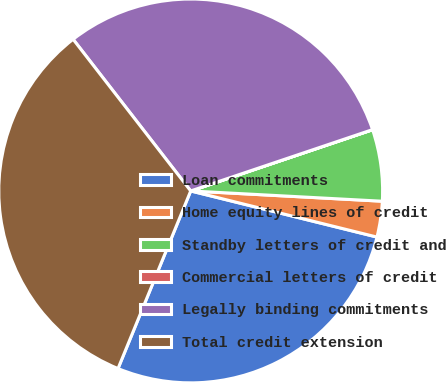Convert chart. <chart><loc_0><loc_0><loc_500><loc_500><pie_chart><fcel>Loan commitments<fcel>Home equity lines of credit<fcel>Standby letters of credit and<fcel>Commercial letters of credit<fcel>Legally binding commitments<fcel>Total credit extension<nl><fcel>27.32%<fcel>3.01%<fcel>6.02%<fcel>0.01%<fcel>30.32%<fcel>33.32%<nl></chart> 